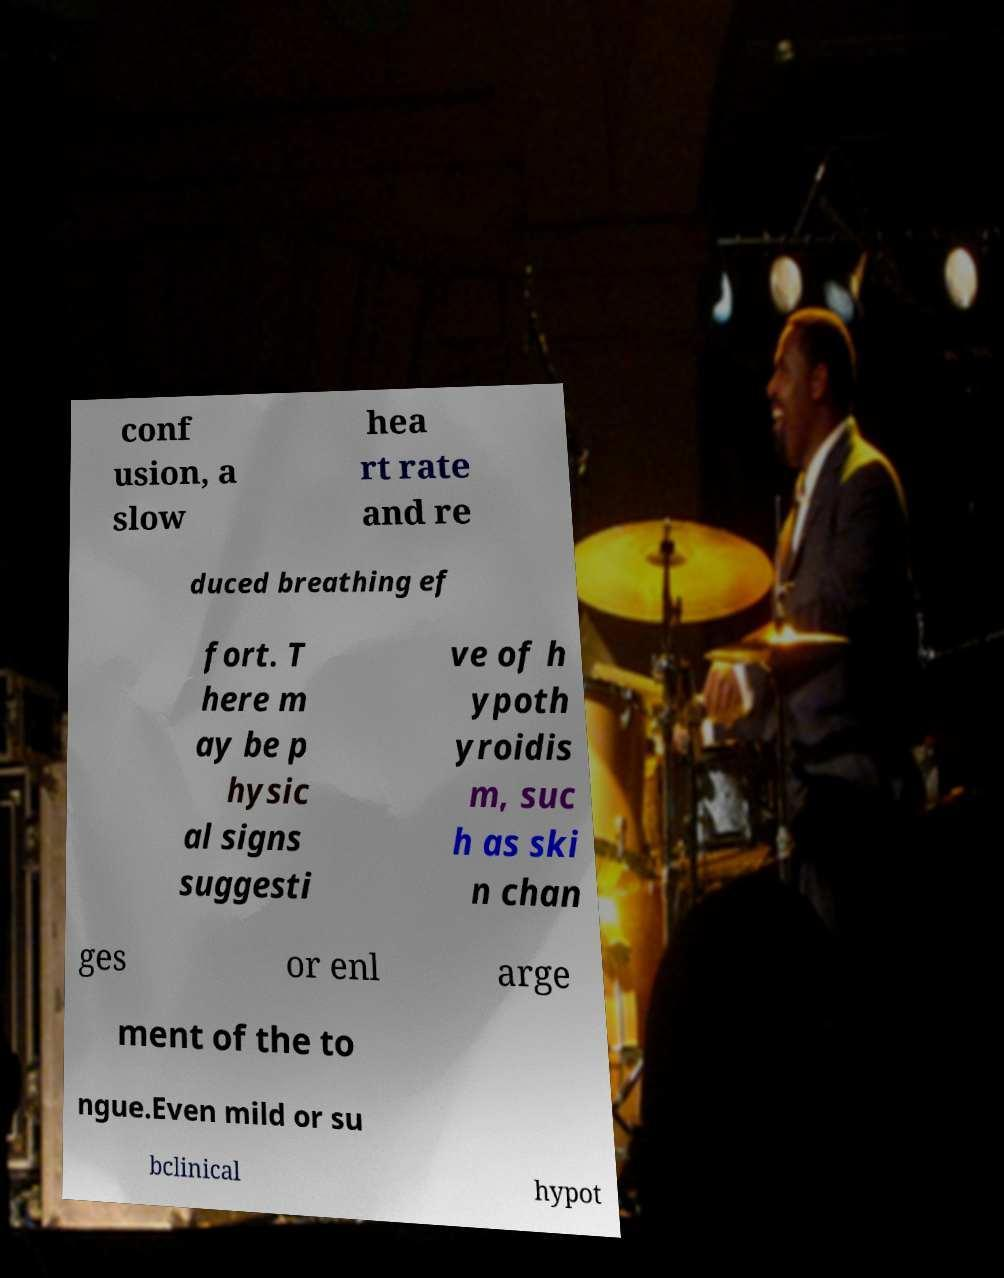Can you read and provide the text displayed in the image?This photo seems to have some interesting text. Can you extract and type it out for me? conf usion, a slow hea rt rate and re duced breathing ef fort. T here m ay be p hysic al signs suggesti ve of h ypoth yroidis m, suc h as ski n chan ges or enl arge ment of the to ngue.Even mild or su bclinical hypot 